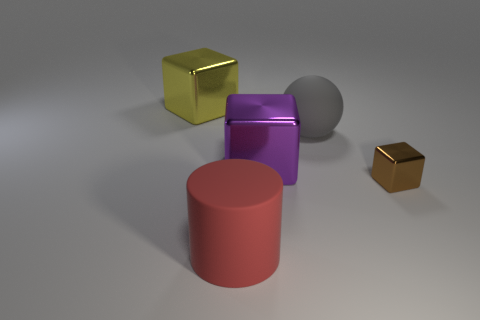What is the color of the rubber ball?
Provide a short and direct response. Gray. There is a thing that is in front of the purple thing and behind the red object; what is its color?
Ensure brevity in your answer.  Brown. Is there any other thing that is made of the same material as the large gray sphere?
Give a very brief answer. Yes. Is the large purple block made of the same material as the big object in front of the small block?
Provide a short and direct response. No. What size is the metallic block that is on the left side of the large rubber thing that is in front of the tiny brown cube?
Provide a short and direct response. Large. Is there any other thing that has the same color as the large ball?
Ensure brevity in your answer.  No. Is the large cube that is on the right side of the big yellow shiny object made of the same material as the big gray ball on the right side of the large purple metal block?
Your answer should be compact. No. What is the material of the block that is both on the left side of the large gray thing and in front of the big gray matte thing?
Your answer should be very brief. Metal. Do the purple metal object and the big metallic thing that is on the left side of the big matte cylinder have the same shape?
Ensure brevity in your answer.  Yes. There is a large cube that is in front of the big shiny cube that is behind the large rubber thing that is right of the big red matte thing; what is it made of?
Your response must be concise. Metal. 